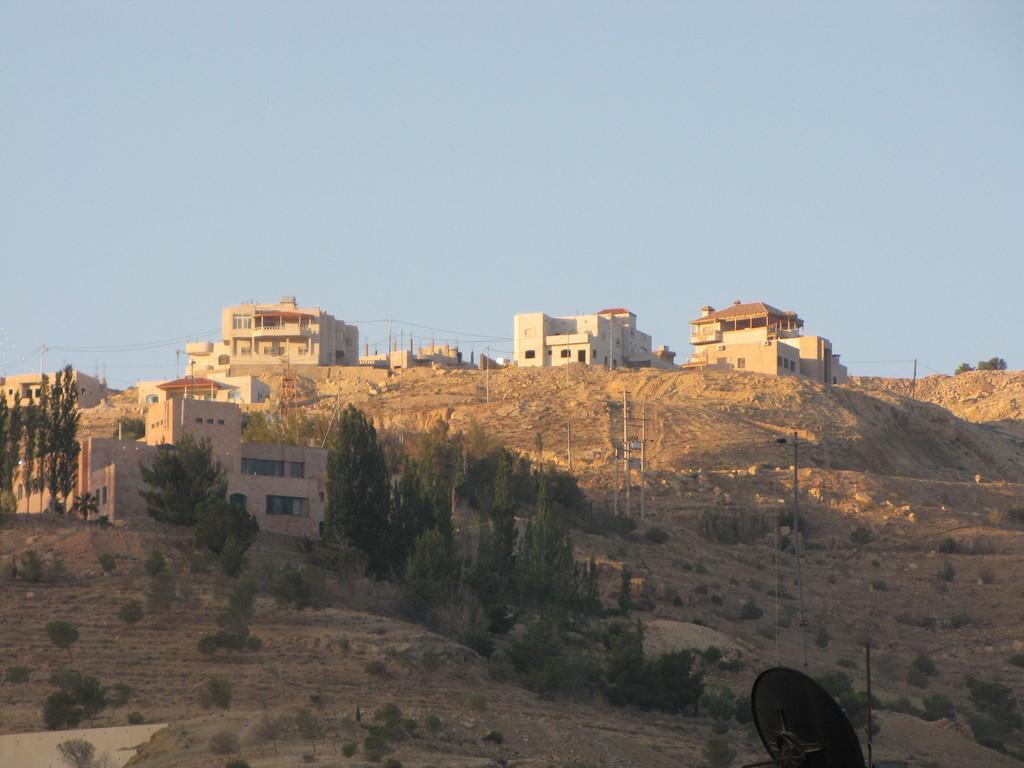Could you give a brief overview of what you see in this image? In this image we can see houses on the hills, current poles, trees, wires and the sky in the background. 